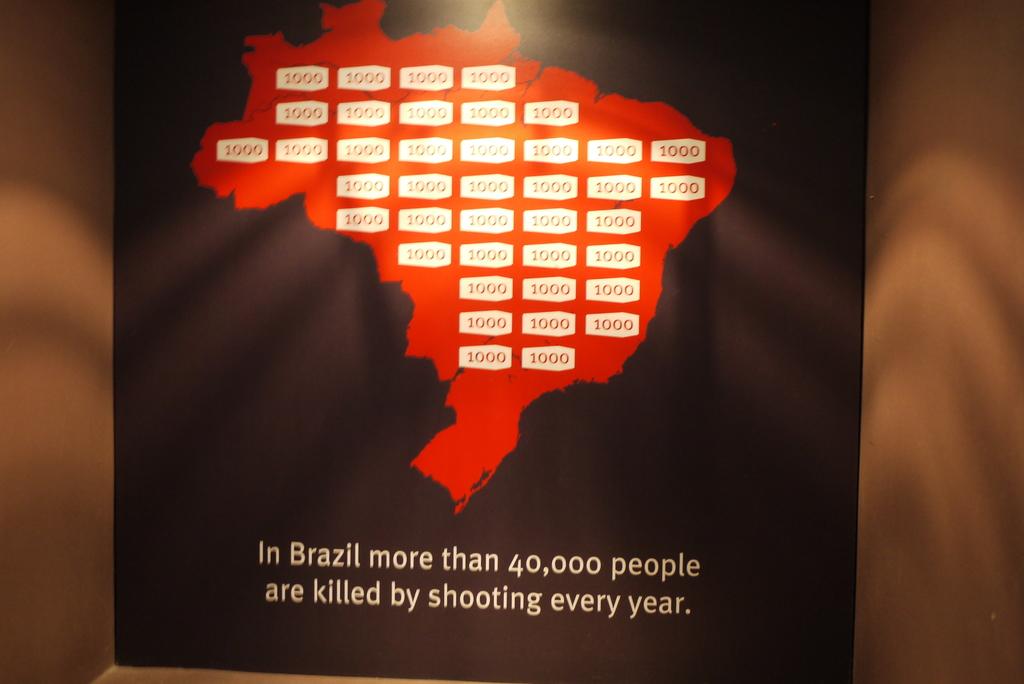How many people are killed by shooting every year?
Provide a succinct answer. 40000. Where is this poster about?
Your answer should be very brief. Brazil. 